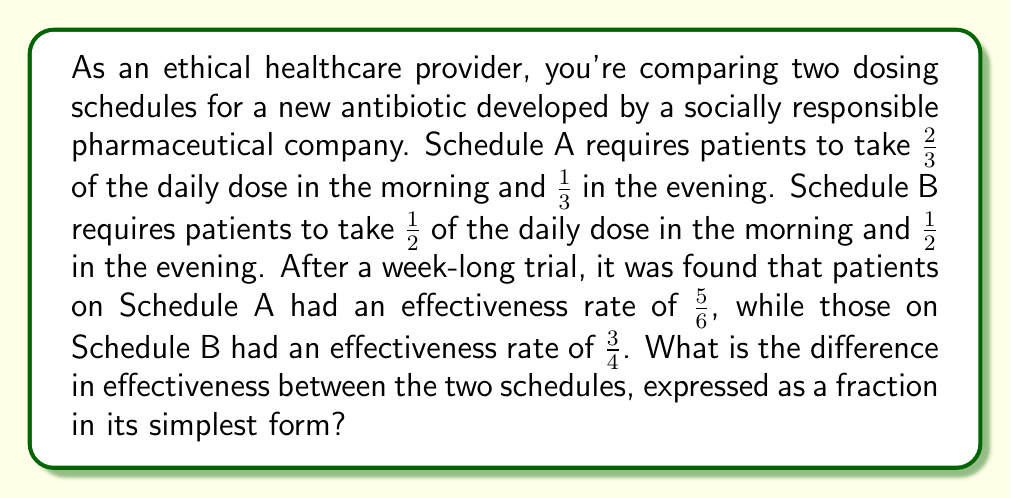Help me with this question. Let's approach this step-by-step:

1) We need to find the difference between the effectiveness rates of Schedule A and Schedule B.

2) Schedule A effectiveness: $\frac{5}{6}$
   Schedule B effectiveness: $\frac{3}{4}$

3) To subtract fractions, we need a common denominator. The least common multiple of 6 and 4 is 12.

4) Let's convert both fractions to equivalent fractions with a denominator of 12:

   $\frac{5}{6} = \frac{5 \times 2}{6 \times 2} = \frac{10}{12}$
   
   $\frac{3}{4} = \frac{3 \times 3}{4 \times 3} = \frac{9}{12}$

5) Now we can subtract:

   $\frac{10}{12} - \frac{9}{12} = \frac{1}{12}$

6) This fraction is already in its simplest form as 1 and 12 have no common factors other than 1.

Therefore, the difference in effectiveness between the two schedules is $\frac{1}{12}$.
Answer: $\frac{1}{12}$ 